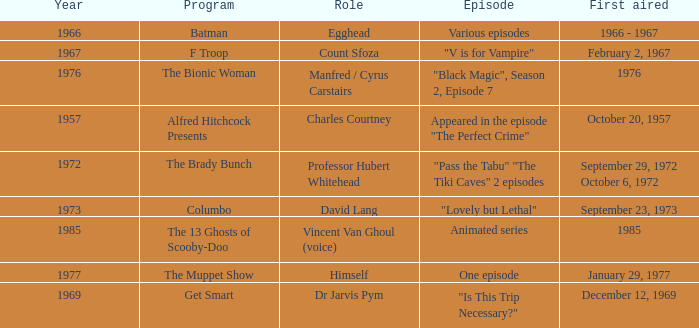What's the roles of the Bionic Woman? Manfred / Cyrus Carstairs. 